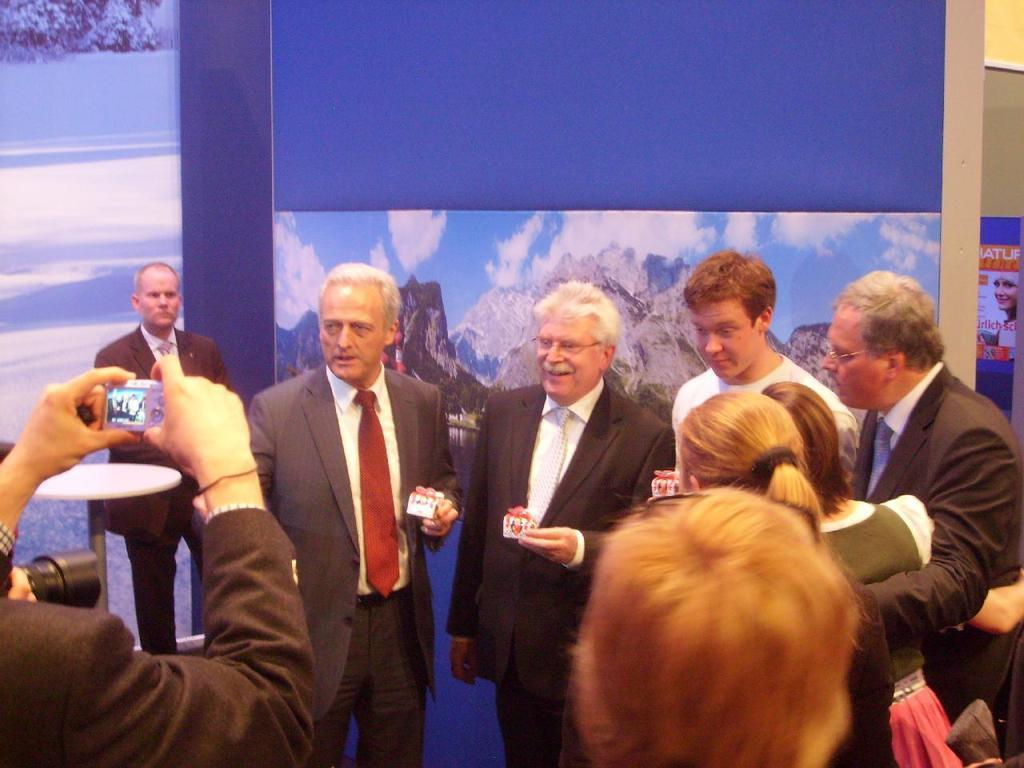What is the main subject of the image? The main subject of the image is a group of people. What are some of the people in the image doing? Some people in the image are holding objects, while others are holding cameras. What can be seen in the background of the image? There are hoardings in the background of the image. Can you tell me how many grapes are being held by the people in the image? There are no grapes present in the image; the people are holding objects and cameras. What type of toothbrush is being used by the people in the image? There is no toothbrush present in the image. 